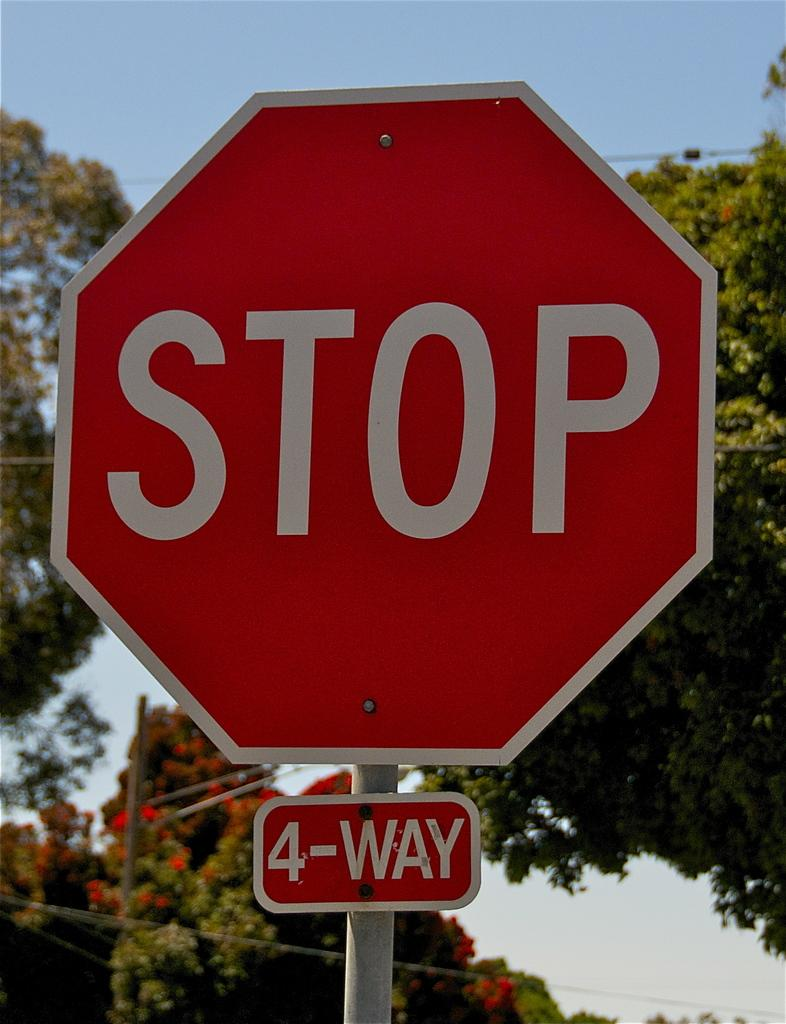<image>
Offer a succinct explanation of the picture presented. A large red sign says Stop 4-Way and trees are in the background. 